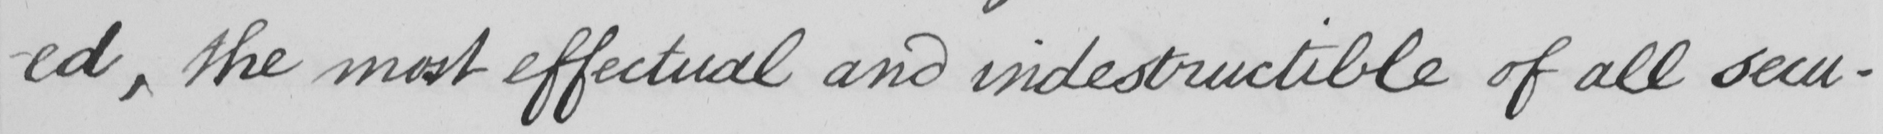Can you tell me what this handwritten text says? -ed , the most effectual and indestructible of all secu- 